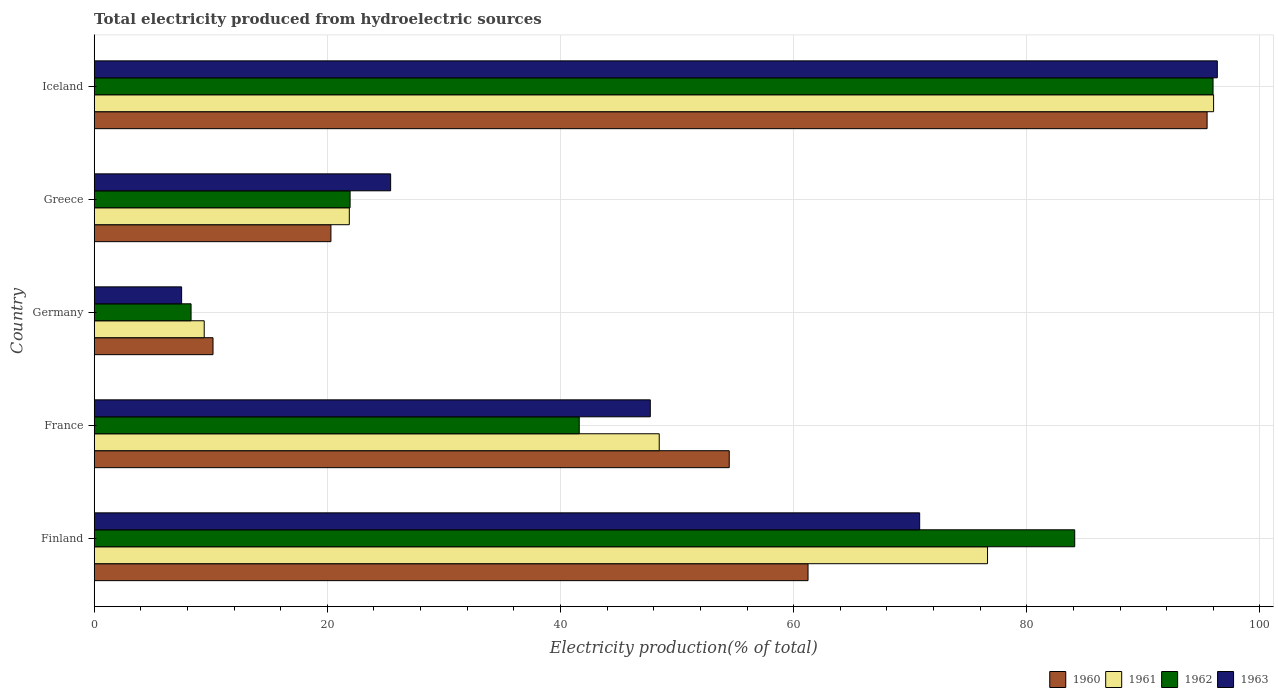How many different coloured bars are there?
Offer a terse response. 4. Are the number of bars per tick equal to the number of legend labels?
Your answer should be very brief. Yes. Are the number of bars on each tick of the Y-axis equal?
Your answer should be compact. Yes. How many bars are there on the 5th tick from the bottom?
Provide a succinct answer. 4. In how many cases, is the number of bars for a given country not equal to the number of legend labels?
Offer a very short reply. 0. What is the total electricity produced in 1962 in Finland?
Ensure brevity in your answer.  84.11. Across all countries, what is the maximum total electricity produced in 1963?
Offer a terse response. 96.34. Across all countries, what is the minimum total electricity produced in 1962?
Keep it short and to the point. 8.31. In which country was the total electricity produced in 1963 minimum?
Your response must be concise. Germany. What is the total total electricity produced in 1963 in the graph?
Offer a terse response. 247.78. What is the difference between the total electricity produced in 1960 in Finland and that in Germany?
Make the answer very short. 51.04. What is the difference between the total electricity produced in 1963 in France and the total electricity produced in 1960 in Germany?
Make the answer very short. 37.51. What is the average total electricity produced in 1963 per country?
Make the answer very short. 49.56. What is the difference between the total electricity produced in 1961 and total electricity produced in 1962 in France?
Keep it short and to the point. 6.86. What is the ratio of the total electricity produced in 1962 in France to that in Germany?
Keep it short and to the point. 5.01. Is the difference between the total electricity produced in 1961 in France and Germany greater than the difference between the total electricity produced in 1962 in France and Germany?
Offer a terse response. Yes. What is the difference between the highest and the second highest total electricity produced in 1962?
Give a very brief answer. 11.87. What is the difference between the highest and the lowest total electricity produced in 1960?
Ensure brevity in your answer.  85.27. In how many countries, is the total electricity produced in 1962 greater than the average total electricity produced in 1962 taken over all countries?
Your answer should be compact. 2. Is it the case that in every country, the sum of the total electricity produced in 1962 and total electricity produced in 1961 is greater than the sum of total electricity produced in 1963 and total electricity produced in 1960?
Ensure brevity in your answer.  No. Is it the case that in every country, the sum of the total electricity produced in 1960 and total electricity produced in 1962 is greater than the total electricity produced in 1961?
Offer a terse response. Yes. How many bars are there?
Provide a succinct answer. 20. Are all the bars in the graph horizontal?
Your answer should be compact. Yes. Does the graph contain any zero values?
Offer a very short reply. No. Does the graph contain grids?
Provide a succinct answer. Yes. Where does the legend appear in the graph?
Make the answer very short. Bottom right. How are the legend labels stacked?
Provide a short and direct response. Horizontal. What is the title of the graph?
Give a very brief answer. Total electricity produced from hydroelectric sources. Does "1963" appear as one of the legend labels in the graph?
Provide a short and direct response. Yes. What is the label or title of the Y-axis?
Provide a succinct answer. Country. What is the Electricity production(% of total) of 1960 in Finland?
Your answer should be compact. 61.23. What is the Electricity production(% of total) of 1961 in Finland?
Your answer should be very brief. 76.63. What is the Electricity production(% of total) in 1962 in Finland?
Keep it short and to the point. 84.11. What is the Electricity production(% of total) in 1963 in Finland?
Your answer should be very brief. 70.81. What is the Electricity production(% of total) in 1960 in France?
Offer a very short reply. 54.47. What is the Electricity production(% of total) of 1961 in France?
Offer a terse response. 48.47. What is the Electricity production(% of total) in 1962 in France?
Your answer should be very brief. 41.61. What is the Electricity production(% of total) in 1963 in France?
Your answer should be compact. 47.7. What is the Electricity production(% of total) in 1960 in Germany?
Your answer should be compact. 10.19. What is the Electricity production(% of total) in 1961 in Germany?
Your answer should be compact. 9.44. What is the Electricity production(% of total) in 1962 in Germany?
Ensure brevity in your answer.  8.31. What is the Electricity production(% of total) in 1963 in Germany?
Provide a short and direct response. 7.5. What is the Electricity production(% of total) in 1960 in Greece?
Your response must be concise. 20.31. What is the Electricity production(% of total) in 1961 in Greece?
Provide a succinct answer. 21.88. What is the Electricity production(% of total) of 1962 in Greece?
Ensure brevity in your answer.  21.95. What is the Electricity production(% of total) of 1963 in Greece?
Provide a short and direct response. 25.43. What is the Electricity production(% of total) in 1960 in Iceland?
Keep it short and to the point. 95.46. What is the Electricity production(% of total) in 1961 in Iceland?
Make the answer very short. 96.02. What is the Electricity production(% of total) of 1962 in Iceland?
Keep it short and to the point. 95.97. What is the Electricity production(% of total) in 1963 in Iceland?
Offer a terse response. 96.34. Across all countries, what is the maximum Electricity production(% of total) of 1960?
Give a very brief answer. 95.46. Across all countries, what is the maximum Electricity production(% of total) in 1961?
Offer a terse response. 96.02. Across all countries, what is the maximum Electricity production(% of total) of 1962?
Offer a terse response. 95.97. Across all countries, what is the maximum Electricity production(% of total) in 1963?
Provide a succinct answer. 96.34. Across all countries, what is the minimum Electricity production(% of total) of 1960?
Make the answer very short. 10.19. Across all countries, what is the minimum Electricity production(% of total) of 1961?
Keep it short and to the point. 9.44. Across all countries, what is the minimum Electricity production(% of total) in 1962?
Your response must be concise. 8.31. Across all countries, what is the minimum Electricity production(% of total) in 1963?
Your answer should be compact. 7.5. What is the total Electricity production(% of total) in 1960 in the graph?
Offer a terse response. 241.67. What is the total Electricity production(% of total) in 1961 in the graph?
Provide a short and direct response. 252.44. What is the total Electricity production(% of total) in 1962 in the graph?
Keep it short and to the point. 251.95. What is the total Electricity production(% of total) in 1963 in the graph?
Your answer should be compact. 247.78. What is the difference between the Electricity production(% of total) in 1960 in Finland and that in France?
Your response must be concise. 6.76. What is the difference between the Electricity production(% of total) in 1961 in Finland and that in France?
Ensure brevity in your answer.  28.16. What is the difference between the Electricity production(% of total) of 1962 in Finland and that in France?
Your response must be concise. 42.5. What is the difference between the Electricity production(% of total) of 1963 in Finland and that in France?
Your answer should be very brief. 23.11. What is the difference between the Electricity production(% of total) in 1960 in Finland and that in Germany?
Offer a very short reply. 51.04. What is the difference between the Electricity production(% of total) of 1961 in Finland and that in Germany?
Provide a succinct answer. 67.19. What is the difference between the Electricity production(% of total) in 1962 in Finland and that in Germany?
Provide a short and direct response. 75.8. What is the difference between the Electricity production(% of total) in 1963 in Finland and that in Germany?
Your answer should be very brief. 63.31. What is the difference between the Electricity production(% of total) in 1960 in Finland and that in Greece?
Offer a terse response. 40.93. What is the difference between the Electricity production(% of total) of 1961 in Finland and that in Greece?
Offer a very short reply. 54.75. What is the difference between the Electricity production(% of total) in 1962 in Finland and that in Greece?
Provide a short and direct response. 62.16. What is the difference between the Electricity production(% of total) of 1963 in Finland and that in Greece?
Ensure brevity in your answer.  45.38. What is the difference between the Electricity production(% of total) in 1960 in Finland and that in Iceland?
Offer a terse response. -34.23. What is the difference between the Electricity production(% of total) in 1961 in Finland and that in Iceland?
Ensure brevity in your answer.  -19.39. What is the difference between the Electricity production(% of total) of 1962 in Finland and that in Iceland?
Keep it short and to the point. -11.87. What is the difference between the Electricity production(% of total) in 1963 in Finland and that in Iceland?
Your response must be concise. -25.53. What is the difference between the Electricity production(% of total) in 1960 in France and that in Germany?
Keep it short and to the point. 44.28. What is the difference between the Electricity production(% of total) in 1961 in France and that in Germany?
Your answer should be very brief. 39.03. What is the difference between the Electricity production(% of total) of 1962 in France and that in Germany?
Offer a very short reply. 33.3. What is the difference between the Electricity production(% of total) in 1963 in France and that in Germany?
Make the answer very short. 40.2. What is the difference between the Electricity production(% of total) of 1960 in France and that in Greece?
Offer a terse response. 34.17. What is the difference between the Electricity production(% of total) in 1961 in France and that in Greece?
Provide a succinct answer. 26.58. What is the difference between the Electricity production(% of total) in 1962 in France and that in Greece?
Give a very brief answer. 19.66. What is the difference between the Electricity production(% of total) of 1963 in France and that in Greece?
Give a very brief answer. 22.27. What is the difference between the Electricity production(% of total) of 1960 in France and that in Iceland?
Offer a terse response. -40.99. What is the difference between the Electricity production(% of total) of 1961 in France and that in Iceland?
Give a very brief answer. -47.55. What is the difference between the Electricity production(% of total) of 1962 in France and that in Iceland?
Your answer should be very brief. -54.37. What is the difference between the Electricity production(% of total) of 1963 in France and that in Iceland?
Provide a short and direct response. -48.64. What is the difference between the Electricity production(% of total) in 1960 in Germany and that in Greece?
Provide a succinct answer. -10.11. What is the difference between the Electricity production(% of total) in 1961 in Germany and that in Greece?
Make the answer very short. -12.45. What is the difference between the Electricity production(% of total) of 1962 in Germany and that in Greece?
Offer a terse response. -13.64. What is the difference between the Electricity production(% of total) in 1963 in Germany and that in Greece?
Provide a short and direct response. -17.93. What is the difference between the Electricity production(% of total) of 1960 in Germany and that in Iceland?
Your response must be concise. -85.27. What is the difference between the Electricity production(% of total) of 1961 in Germany and that in Iceland?
Provide a succinct answer. -86.58. What is the difference between the Electricity production(% of total) of 1962 in Germany and that in Iceland?
Your answer should be compact. -87.67. What is the difference between the Electricity production(% of total) of 1963 in Germany and that in Iceland?
Give a very brief answer. -88.84. What is the difference between the Electricity production(% of total) in 1960 in Greece and that in Iceland?
Offer a terse response. -75.16. What is the difference between the Electricity production(% of total) of 1961 in Greece and that in Iceland?
Offer a very short reply. -74.14. What is the difference between the Electricity production(% of total) of 1962 in Greece and that in Iceland?
Offer a terse response. -74.02. What is the difference between the Electricity production(% of total) of 1963 in Greece and that in Iceland?
Make the answer very short. -70.91. What is the difference between the Electricity production(% of total) of 1960 in Finland and the Electricity production(% of total) of 1961 in France?
Your answer should be compact. 12.76. What is the difference between the Electricity production(% of total) in 1960 in Finland and the Electricity production(% of total) in 1962 in France?
Your answer should be compact. 19.63. What is the difference between the Electricity production(% of total) of 1960 in Finland and the Electricity production(% of total) of 1963 in France?
Offer a very short reply. 13.53. What is the difference between the Electricity production(% of total) of 1961 in Finland and the Electricity production(% of total) of 1962 in France?
Provide a succinct answer. 35.02. What is the difference between the Electricity production(% of total) of 1961 in Finland and the Electricity production(% of total) of 1963 in France?
Provide a short and direct response. 28.93. What is the difference between the Electricity production(% of total) in 1962 in Finland and the Electricity production(% of total) in 1963 in France?
Give a very brief answer. 36.41. What is the difference between the Electricity production(% of total) of 1960 in Finland and the Electricity production(% of total) of 1961 in Germany?
Give a very brief answer. 51.8. What is the difference between the Electricity production(% of total) of 1960 in Finland and the Electricity production(% of total) of 1962 in Germany?
Ensure brevity in your answer.  52.92. What is the difference between the Electricity production(% of total) in 1960 in Finland and the Electricity production(% of total) in 1963 in Germany?
Give a very brief answer. 53.73. What is the difference between the Electricity production(% of total) in 1961 in Finland and the Electricity production(% of total) in 1962 in Germany?
Your answer should be compact. 68.32. What is the difference between the Electricity production(% of total) of 1961 in Finland and the Electricity production(% of total) of 1963 in Germany?
Offer a very short reply. 69.13. What is the difference between the Electricity production(% of total) in 1962 in Finland and the Electricity production(% of total) in 1963 in Germany?
Your answer should be compact. 76.61. What is the difference between the Electricity production(% of total) in 1960 in Finland and the Electricity production(% of total) in 1961 in Greece?
Your answer should be compact. 39.35. What is the difference between the Electricity production(% of total) of 1960 in Finland and the Electricity production(% of total) of 1962 in Greece?
Ensure brevity in your answer.  39.28. What is the difference between the Electricity production(% of total) in 1960 in Finland and the Electricity production(% of total) in 1963 in Greece?
Offer a terse response. 35.8. What is the difference between the Electricity production(% of total) of 1961 in Finland and the Electricity production(% of total) of 1962 in Greece?
Offer a terse response. 54.68. What is the difference between the Electricity production(% of total) of 1961 in Finland and the Electricity production(% of total) of 1963 in Greece?
Keep it short and to the point. 51.2. What is the difference between the Electricity production(% of total) of 1962 in Finland and the Electricity production(% of total) of 1963 in Greece?
Give a very brief answer. 58.68. What is the difference between the Electricity production(% of total) in 1960 in Finland and the Electricity production(% of total) in 1961 in Iceland?
Ensure brevity in your answer.  -34.79. What is the difference between the Electricity production(% of total) of 1960 in Finland and the Electricity production(% of total) of 1962 in Iceland?
Provide a succinct answer. -34.74. What is the difference between the Electricity production(% of total) of 1960 in Finland and the Electricity production(% of total) of 1963 in Iceland?
Your answer should be very brief. -35.11. What is the difference between the Electricity production(% of total) in 1961 in Finland and the Electricity production(% of total) in 1962 in Iceland?
Offer a very short reply. -19.35. What is the difference between the Electricity production(% of total) in 1961 in Finland and the Electricity production(% of total) in 1963 in Iceland?
Provide a succinct answer. -19.71. What is the difference between the Electricity production(% of total) in 1962 in Finland and the Electricity production(% of total) in 1963 in Iceland?
Make the answer very short. -12.23. What is the difference between the Electricity production(% of total) of 1960 in France and the Electricity production(% of total) of 1961 in Germany?
Give a very brief answer. 45.04. What is the difference between the Electricity production(% of total) of 1960 in France and the Electricity production(% of total) of 1962 in Germany?
Your answer should be very brief. 46.16. What is the difference between the Electricity production(% of total) in 1960 in France and the Electricity production(% of total) in 1963 in Germany?
Your answer should be compact. 46.97. What is the difference between the Electricity production(% of total) in 1961 in France and the Electricity production(% of total) in 1962 in Germany?
Provide a short and direct response. 40.16. What is the difference between the Electricity production(% of total) of 1961 in France and the Electricity production(% of total) of 1963 in Germany?
Keep it short and to the point. 40.97. What is the difference between the Electricity production(% of total) in 1962 in France and the Electricity production(% of total) in 1963 in Germany?
Provide a succinct answer. 34.11. What is the difference between the Electricity production(% of total) of 1960 in France and the Electricity production(% of total) of 1961 in Greece?
Provide a succinct answer. 32.59. What is the difference between the Electricity production(% of total) in 1960 in France and the Electricity production(% of total) in 1962 in Greece?
Your answer should be very brief. 32.52. What is the difference between the Electricity production(% of total) in 1960 in France and the Electricity production(% of total) in 1963 in Greece?
Offer a terse response. 29.05. What is the difference between the Electricity production(% of total) of 1961 in France and the Electricity production(% of total) of 1962 in Greece?
Offer a terse response. 26.52. What is the difference between the Electricity production(% of total) in 1961 in France and the Electricity production(% of total) in 1963 in Greece?
Ensure brevity in your answer.  23.04. What is the difference between the Electricity production(% of total) of 1962 in France and the Electricity production(% of total) of 1963 in Greece?
Provide a succinct answer. 16.18. What is the difference between the Electricity production(% of total) in 1960 in France and the Electricity production(% of total) in 1961 in Iceland?
Your answer should be very brief. -41.55. What is the difference between the Electricity production(% of total) in 1960 in France and the Electricity production(% of total) in 1962 in Iceland?
Offer a very short reply. -41.5. What is the difference between the Electricity production(% of total) in 1960 in France and the Electricity production(% of total) in 1963 in Iceland?
Give a very brief answer. -41.87. What is the difference between the Electricity production(% of total) in 1961 in France and the Electricity production(% of total) in 1962 in Iceland?
Give a very brief answer. -47.51. What is the difference between the Electricity production(% of total) of 1961 in France and the Electricity production(% of total) of 1963 in Iceland?
Offer a very short reply. -47.87. What is the difference between the Electricity production(% of total) in 1962 in France and the Electricity production(% of total) in 1963 in Iceland?
Offer a terse response. -54.74. What is the difference between the Electricity production(% of total) of 1960 in Germany and the Electricity production(% of total) of 1961 in Greece?
Keep it short and to the point. -11.69. What is the difference between the Electricity production(% of total) in 1960 in Germany and the Electricity production(% of total) in 1962 in Greece?
Offer a terse response. -11.76. What is the difference between the Electricity production(% of total) in 1960 in Germany and the Electricity production(% of total) in 1963 in Greece?
Your answer should be very brief. -15.24. What is the difference between the Electricity production(% of total) of 1961 in Germany and the Electricity production(% of total) of 1962 in Greece?
Offer a very short reply. -12.51. What is the difference between the Electricity production(% of total) in 1961 in Germany and the Electricity production(% of total) in 1963 in Greece?
Your answer should be very brief. -15.99. What is the difference between the Electricity production(% of total) in 1962 in Germany and the Electricity production(% of total) in 1963 in Greece?
Offer a terse response. -17.12. What is the difference between the Electricity production(% of total) in 1960 in Germany and the Electricity production(% of total) in 1961 in Iceland?
Provide a succinct answer. -85.83. What is the difference between the Electricity production(% of total) of 1960 in Germany and the Electricity production(% of total) of 1962 in Iceland?
Provide a short and direct response. -85.78. What is the difference between the Electricity production(% of total) in 1960 in Germany and the Electricity production(% of total) in 1963 in Iceland?
Keep it short and to the point. -86.15. What is the difference between the Electricity production(% of total) of 1961 in Germany and the Electricity production(% of total) of 1962 in Iceland?
Provide a succinct answer. -86.54. What is the difference between the Electricity production(% of total) of 1961 in Germany and the Electricity production(% of total) of 1963 in Iceland?
Give a very brief answer. -86.9. What is the difference between the Electricity production(% of total) in 1962 in Germany and the Electricity production(% of total) in 1963 in Iceland?
Offer a very short reply. -88.03. What is the difference between the Electricity production(% of total) of 1960 in Greece and the Electricity production(% of total) of 1961 in Iceland?
Offer a very short reply. -75.71. What is the difference between the Electricity production(% of total) of 1960 in Greece and the Electricity production(% of total) of 1962 in Iceland?
Ensure brevity in your answer.  -75.67. What is the difference between the Electricity production(% of total) in 1960 in Greece and the Electricity production(% of total) in 1963 in Iceland?
Offer a terse response. -76.04. What is the difference between the Electricity production(% of total) of 1961 in Greece and the Electricity production(% of total) of 1962 in Iceland?
Give a very brief answer. -74.09. What is the difference between the Electricity production(% of total) in 1961 in Greece and the Electricity production(% of total) in 1963 in Iceland?
Make the answer very short. -74.46. What is the difference between the Electricity production(% of total) of 1962 in Greece and the Electricity production(% of total) of 1963 in Iceland?
Ensure brevity in your answer.  -74.39. What is the average Electricity production(% of total) in 1960 per country?
Keep it short and to the point. 48.33. What is the average Electricity production(% of total) in 1961 per country?
Offer a terse response. 50.49. What is the average Electricity production(% of total) in 1962 per country?
Your response must be concise. 50.39. What is the average Electricity production(% of total) in 1963 per country?
Offer a terse response. 49.56. What is the difference between the Electricity production(% of total) of 1960 and Electricity production(% of total) of 1961 in Finland?
Give a very brief answer. -15.4. What is the difference between the Electricity production(% of total) of 1960 and Electricity production(% of total) of 1962 in Finland?
Offer a very short reply. -22.88. What is the difference between the Electricity production(% of total) in 1960 and Electricity production(% of total) in 1963 in Finland?
Your answer should be compact. -9.58. What is the difference between the Electricity production(% of total) of 1961 and Electricity production(% of total) of 1962 in Finland?
Provide a short and direct response. -7.48. What is the difference between the Electricity production(% of total) in 1961 and Electricity production(% of total) in 1963 in Finland?
Offer a terse response. 5.82. What is the difference between the Electricity production(% of total) in 1962 and Electricity production(% of total) in 1963 in Finland?
Your answer should be compact. 13.3. What is the difference between the Electricity production(% of total) in 1960 and Electricity production(% of total) in 1961 in France?
Your response must be concise. 6.01. What is the difference between the Electricity production(% of total) in 1960 and Electricity production(% of total) in 1962 in France?
Ensure brevity in your answer.  12.87. What is the difference between the Electricity production(% of total) in 1960 and Electricity production(% of total) in 1963 in France?
Make the answer very short. 6.77. What is the difference between the Electricity production(% of total) in 1961 and Electricity production(% of total) in 1962 in France?
Give a very brief answer. 6.86. What is the difference between the Electricity production(% of total) of 1961 and Electricity production(% of total) of 1963 in France?
Ensure brevity in your answer.  0.77. What is the difference between the Electricity production(% of total) of 1962 and Electricity production(% of total) of 1963 in France?
Provide a short and direct response. -6.1. What is the difference between the Electricity production(% of total) of 1960 and Electricity production(% of total) of 1961 in Germany?
Ensure brevity in your answer.  0.76. What is the difference between the Electricity production(% of total) of 1960 and Electricity production(% of total) of 1962 in Germany?
Ensure brevity in your answer.  1.88. What is the difference between the Electricity production(% of total) in 1960 and Electricity production(% of total) in 1963 in Germany?
Your answer should be very brief. 2.69. What is the difference between the Electricity production(% of total) of 1961 and Electricity production(% of total) of 1962 in Germany?
Your answer should be very brief. 1.13. What is the difference between the Electricity production(% of total) of 1961 and Electricity production(% of total) of 1963 in Germany?
Offer a very short reply. 1.94. What is the difference between the Electricity production(% of total) of 1962 and Electricity production(% of total) of 1963 in Germany?
Your answer should be very brief. 0.81. What is the difference between the Electricity production(% of total) of 1960 and Electricity production(% of total) of 1961 in Greece?
Provide a short and direct response. -1.58. What is the difference between the Electricity production(% of total) of 1960 and Electricity production(% of total) of 1962 in Greece?
Provide a succinct answer. -1.64. What is the difference between the Electricity production(% of total) in 1960 and Electricity production(% of total) in 1963 in Greece?
Offer a terse response. -5.12. What is the difference between the Electricity production(% of total) of 1961 and Electricity production(% of total) of 1962 in Greece?
Offer a very short reply. -0.07. What is the difference between the Electricity production(% of total) in 1961 and Electricity production(% of total) in 1963 in Greece?
Offer a very short reply. -3.54. What is the difference between the Electricity production(% of total) in 1962 and Electricity production(% of total) in 1963 in Greece?
Offer a very short reply. -3.48. What is the difference between the Electricity production(% of total) of 1960 and Electricity production(% of total) of 1961 in Iceland?
Your answer should be compact. -0.56. What is the difference between the Electricity production(% of total) in 1960 and Electricity production(% of total) in 1962 in Iceland?
Ensure brevity in your answer.  -0.51. What is the difference between the Electricity production(% of total) in 1960 and Electricity production(% of total) in 1963 in Iceland?
Your response must be concise. -0.88. What is the difference between the Electricity production(% of total) of 1961 and Electricity production(% of total) of 1962 in Iceland?
Your answer should be compact. 0.05. What is the difference between the Electricity production(% of total) in 1961 and Electricity production(% of total) in 1963 in Iceland?
Give a very brief answer. -0.32. What is the difference between the Electricity production(% of total) of 1962 and Electricity production(% of total) of 1963 in Iceland?
Your response must be concise. -0.37. What is the ratio of the Electricity production(% of total) in 1960 in Finland to that in France?
Keep it short and to the point. 1.12. What is the ratio of the Electricity production(% of total) of 1961 in Finland to that in France?
Provide a succinct answer. 1.58. What is the ratio of the Electricity production(% of total) in 1962 in Finland to that in France?
Your response must be concise. 2.02. What is the ratio of the Electricity production(% of total) in 1963 in Finland to that in France?
Ensure brevity in your answer.  1.48. What is the ratio of the Electricity production(% of total) in 1960 in Finland to that in Germany?
Provide a short and direct response. 6.01. What is the ratio of the Electricity production(% of total) in 1961 in Finland to that in Germany?
Make the answer very short. 8.12. What is the ratio of the Electricity production(% of total) in 1962 in Finland to that in Germany?
Keep it short and to the point. 10.12. What is the ratio of the Electricity production(% of total) in 1963 in Finland to that in Germany?
Your answer should be compact. 9.44. What is the ratio of the Electricity production(% of total) of 1960 in Finland to that in Greece?
Offer a terse response. 3.02. What is the ratio of the Electricity production(% of total) of 1961 in Finland to that in Greece?
Your answer should be very brief. 3.5. What is the ratio of the Electricity production(% of total) in 1962 in Finland to that in Greece?
Offer a very short reply. 3.83. What is the ratio of the Electricity production(% of total) of 1963 in Finland to that in Greece?
Offer a terse response. 2.78. What is the ratio of the Electricity production(% of total) of 1960 in Finland to that in Iceland?
Provide a short and direct response. 0.64. What is the ratio of the Electricity production(% of total) in 1961 in Finland to that in Iceland?
Provide a short and direct response. 0.8. What is the ratio of the Electricity production(% of total) of 1962 in Finland to that in Iceland?
Make the answer very short. 0.88. What is the ratio of the Electricity production(% of total) of 1963 in Finland to that in Iceland?
Offer a terse response. 0.73. What is the ratio of the Electricity production(% of total) in 1960 in France to that in Germany?
Ensure brevity in your answer.  5.34. What is the ratio of the Electricity production(% of total) of 1961 in France to that in Germany?
Your answer should be very brief. 5.14. What is the ratio of the Electricity production(% of total) in 1962 in France to that in Germany?
Offer a very short reply. 5.01. What is the ratio of the Electricity production(% of total) in 1963 in France to that in Germany?
Offer a terse response. 6.36. What is the ratio of the Electricity production(% of total) of 1960 in France to that in Greece?
Make the answer very short. 2.68. What is the ratio of the Electricity production(% of total) of 1961 in France to that in Greece?
Ensure brevity in your answer.  2.21. What is the ratio of the Electricity production(% of total) in 1962 in France to that in Greece?
Your answer should be very brief. 1.9. What is the ratio of the Electricity production(% of total) of 1963 in France to that in Greece?
Offer a very short reply. 1.88. What is the ratio of the Electricity production(% of total) of 1960 in France to that in Iceland?
Your answer should be very brief. 0.57. What is the ratio of the Electricity production(% of total) of 1961 in France to that in Iceland?
Offer a very short reply. 0.5. What is the ratio of the Electricity production(% of total) in 1962 in France to that in Iceland?
Give a very brief answer. 0.43. What is the ratio of the Electricity production(% of total) in 1963 in France to that in Iceland?
Your answer should be very brief. 0.5. What is the ratio of the Electricity production(% of total) in 1960 in Germany to that in Greece?
Your answer should be compact. 0.5. What is the ratio of the Electricity production(% of total) in 1961 in Germany to that in Greece?
Your answer should be compact. 0.43. What is the ratio of the Electricity production(% of total) in 1962 in Germany to that in Greece?
Ensure brevity in your answer.  0.38. What is the ratio of the Electricity production(% of total) in 1963 in Germany to that in Greece?
Provide a succinct answer. 0.29. What is the ratio of the Electricity production(% of total) of 1960 in Germany to that in Iceland?
Your answer should be very brief. 0.11. What is the ratio of the Electricity production(% of total) of 1961 in Germany to that in Iceland?
Your answer should be compact. 0.1. What is the ratio of the Electricity production(% of total) of 1962 in Germany to that in Iceland?
Provide a succinct answer. 0.09. What is the ratio of the Electricity production(% of total) in 1963 in Germany to that in Iceland?
Your answer should be compact. 0.08. What is the ratio of the Electricity production(% of total) in 1960 in Greece to that in Iceland?
Your response must be concise. 0.21. What is the ratio of the Electricity production(% of total) in 1961 in Greece to that in Iceland?
Keep it short and to the point. 0.23. What is the ratio of the Electricity production(% of total) of 1962 in Greece to that in Iceland?
Offer a very short reply. 0.23. What is the ratio of the Electricity production(% of total) of 1963 in Greece to that in Iceland?
Your answer should be compact. 0.26. What is the difference between the highest and the second highest Electricity production(% of total) in 1960?
Your answer should be very brief. 34.23. What is the difference between the highest and the second highest Electricity production(% of total) in 1961?
Your answer should be compact. 19.39. What is the difference between the highest and the second highest Electricity production(% of total) in 1962?
Give a very brief answer. 11.87. What is the difference between the highest and the second highest Electricity production(% of total) of 1963?
Ensure brevity in your answer.  25.53. What is the difference between the highest and the lowest Electricity production(% of total) of 1960?
Your response must be concise. 85.27. What is the difference between the highest and the lowest Electricity production(% of total) of 1961?
Offer a terse response. 86.58. What is the difference between the highest and the lowest Electricity production(% of total) of 1962?
Offer a terse response. 87.67. What is the difference between the highest and the lowest Electricity production(% of total) in 1963?
Ensure brevity in your answer.  88.84. 